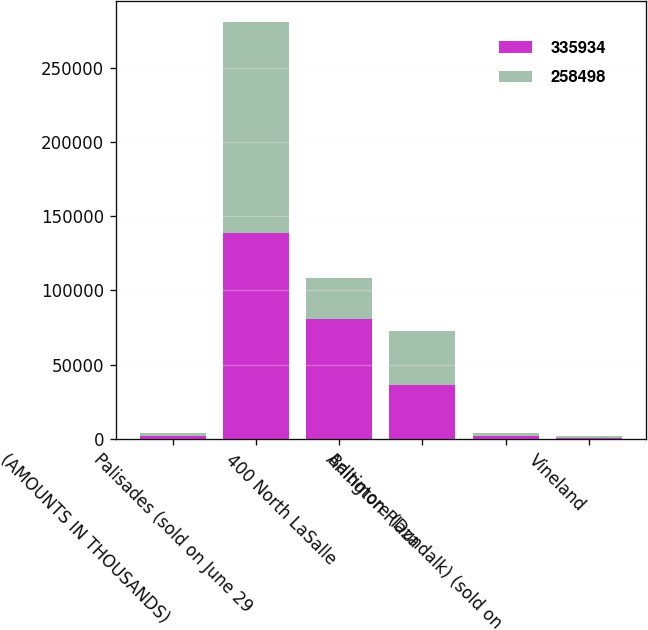Convert chart. <chart><loc_0><loc_0><loc_500><loc_500><stacked_bar_chart><ecel><fcel>(AMOUNTS IN THOUSANDS)<fcel>Palisades (sold on June 29<fcel>400 North LaSalle<fcel>Arlington Plaza<fcel>Baltimore (Dundalk) (sold on<fcel>Vineland<nl><fcel>335934<fcel>2003<fcel>138629<fcel>80685<fcel>36109<fcel>2167<fcel>908<nl><fcel>258498<fcel>2002<fcel>142333<fcel>27600<fcel>36666<fcel>2050<fcel>978<nl></chart> 